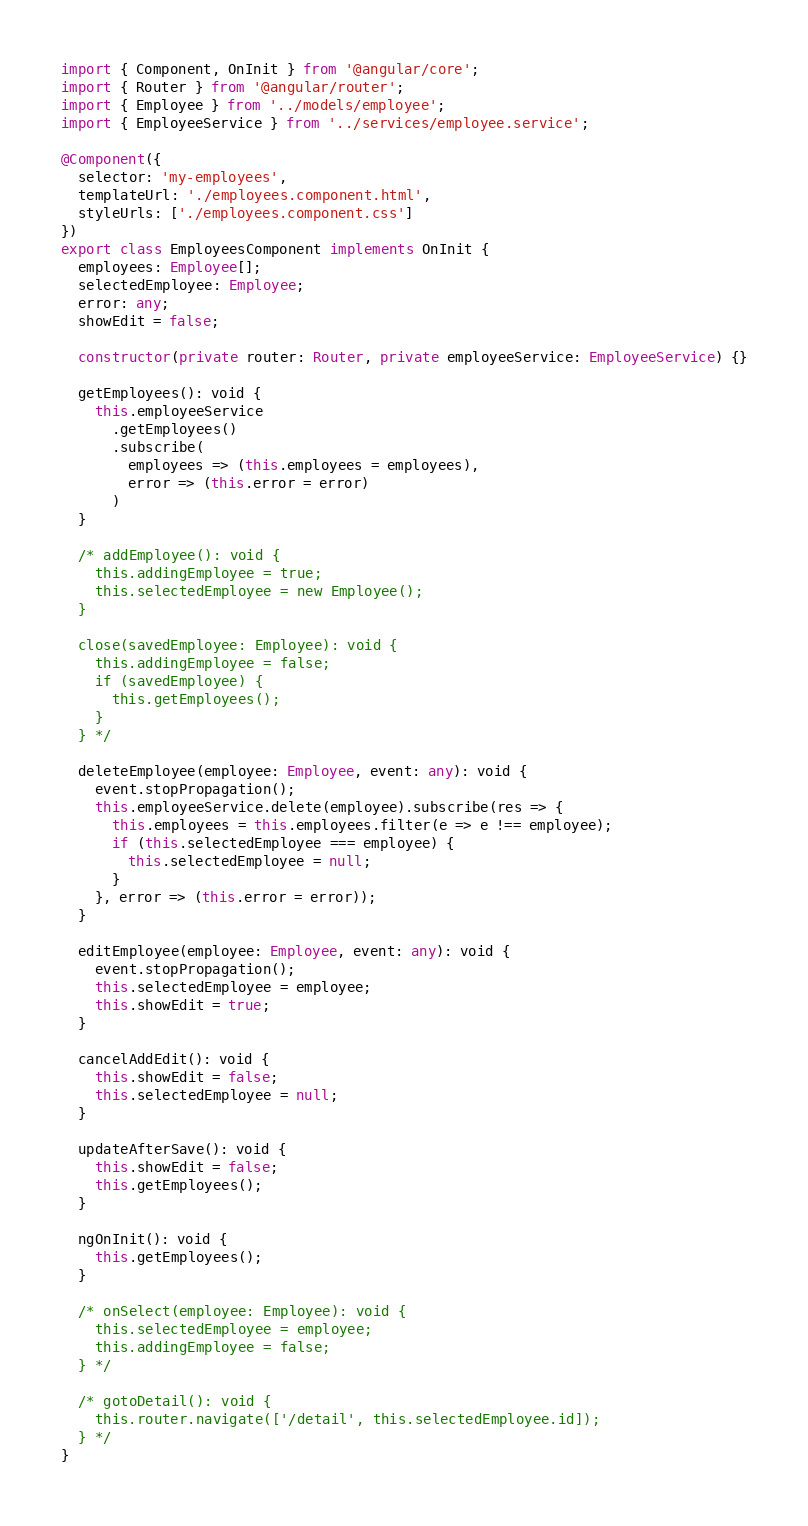Convert code to text. <code><loc_0><loc_0><loc_500><loc_500><_TypeScript_>import { Component, OnInit } from '@angular/core';
import { Router } from '@angular/router';
import { Employee } from '../models/employee';
import { EmployeeService } from '../services/employee.service';

@Component({
  selector: 'my-employees',
  templateUrl: './employees.component.html',
  styleUrls: ['./employees.component.css']
})
export class EmployeesComponent implements OnInit {
  employees: Employee[];
  selectedEmployee: Employee;
  error: any;
  showEdit = false;

  constructor(private router: Router, private employeeService: EmployeeService) {}

  getEmployees(): void {
    this.employeeService
      .getEmployees()
      .subscribe(
        employees => (this.employees = employees),
        error => (this.error = error)
      )
  }

  /* addEmployee(): void {
    this.addingEmployee = true;
    this.selectedEmployee = new Employee();
  }

  close(savedEmployee: Employee): void {
    this.addingEmployee = false;
    if (savedEmployee) {
      this.getEmployees();
    }
  } */

  deleteEmployee(employee: Employee, event: any): void {
    event.stopPropagation();
    this.employeeService.delete(employee).subscribe(res => {
      this.employees = this.employees.filter(e => e !== employee);
      if (this.selectedEmployee === employee) {
        this.selectedEmployee = null;
      }
    }, error => (this.error = error));
  }

  editEmployee(employee: Employee, event: any): void {
    event.stopPropagation();
    this.selectedEmployee = employee;
    this.showEdit = true;
  }

  cancelAddEdit(): void {
    this.showEdit = false;
    this.selectedEmployee = null;
  }

  updateAfterSave(): void {
    this.showEdit = false;
    this.getEmployees();
  }

  ngOnInit(): void {
    this.getEmployees();
  }

  /* onSelect(employee: Employee): void {
    this.selectedEmployee = employee;
    this.addingEmployee = false;
  } */

  /* gotoDetail(): void {
    this.router.navigate(['/detail', this.selectedEmployee.id]);
  } */
}
</code> 